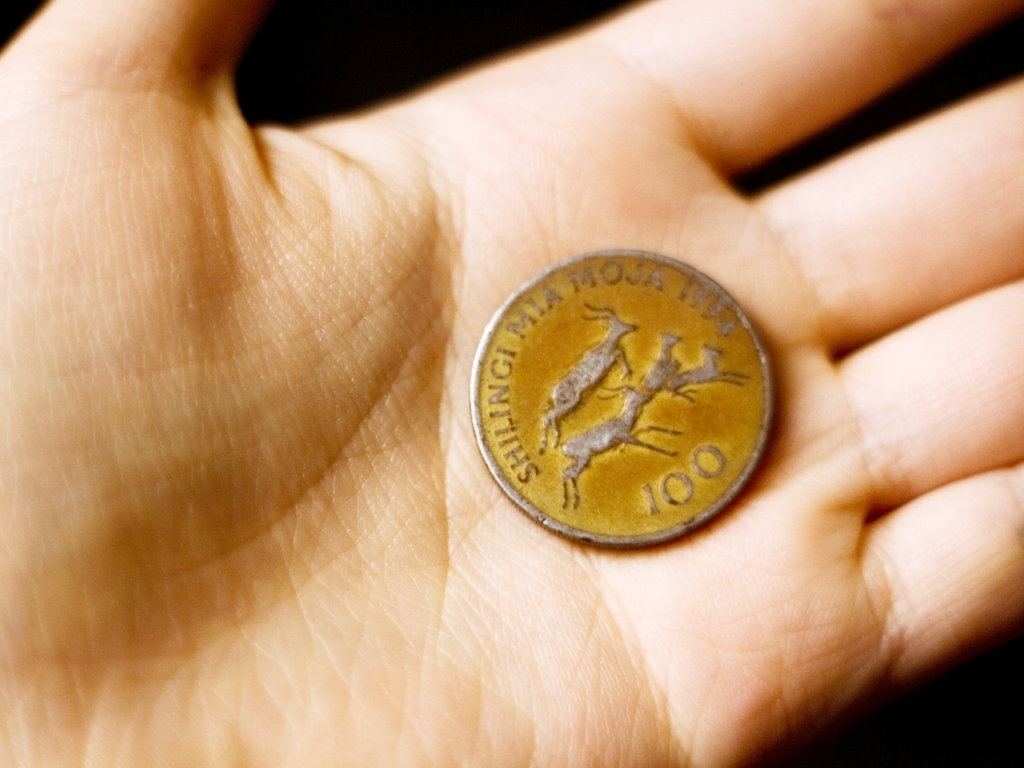Are the texture details of the coin preserved? The image reveals that the coin retains many of its texture details, with clear visibility of both the embossed elements like the figure and numerals, and finer aspects such as slight wear or patina, which point towards the coin's historical usage and preservation. 